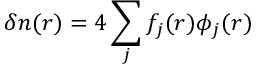<formula> <loc_0><loc_0><loc_500><loc_500>\delta n ( r ) = 4 \sum _ { j } f _ { j } ( r ) \phi _ { j } ( r )</formula> 